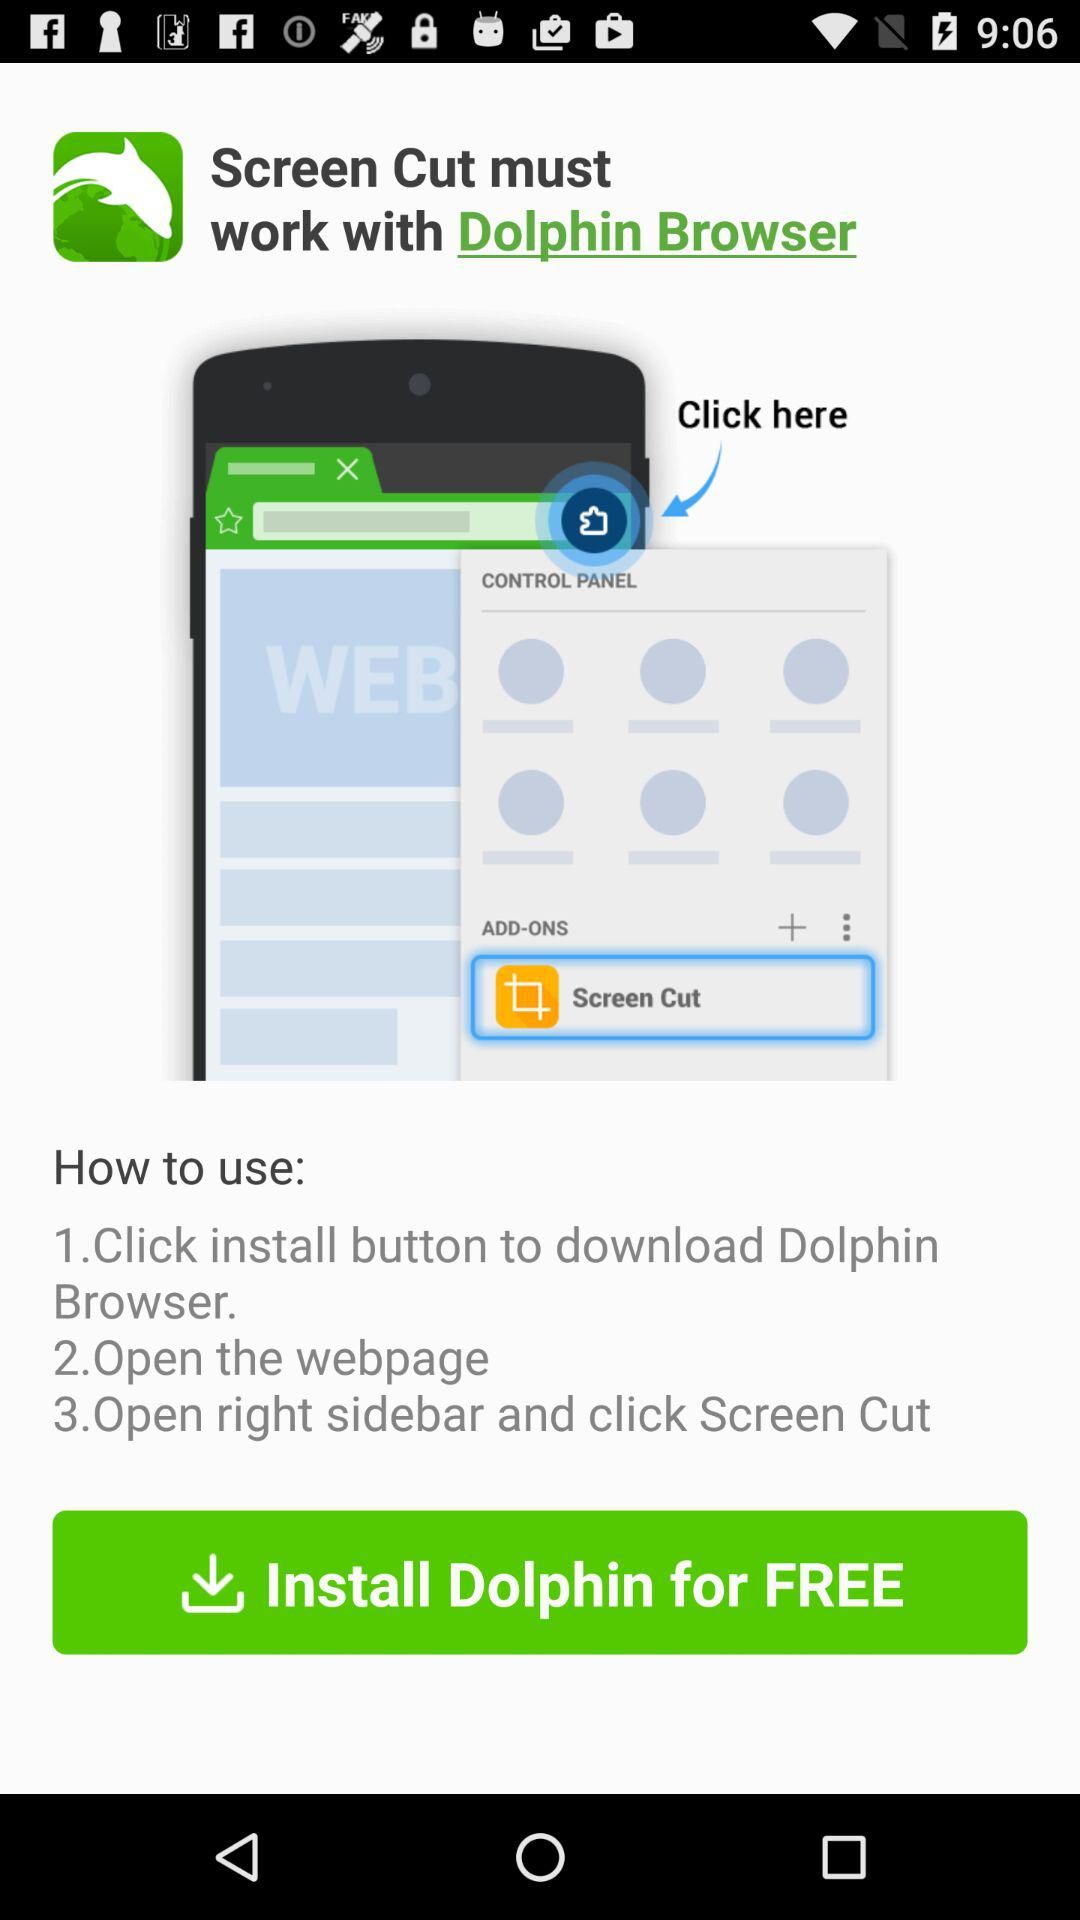What are the steps to use "Dolphin Browser"? The steps are "Click install button to download Dolphin Browser", "Open the webpage", and "Open right sidebar and click Screen Cut". 